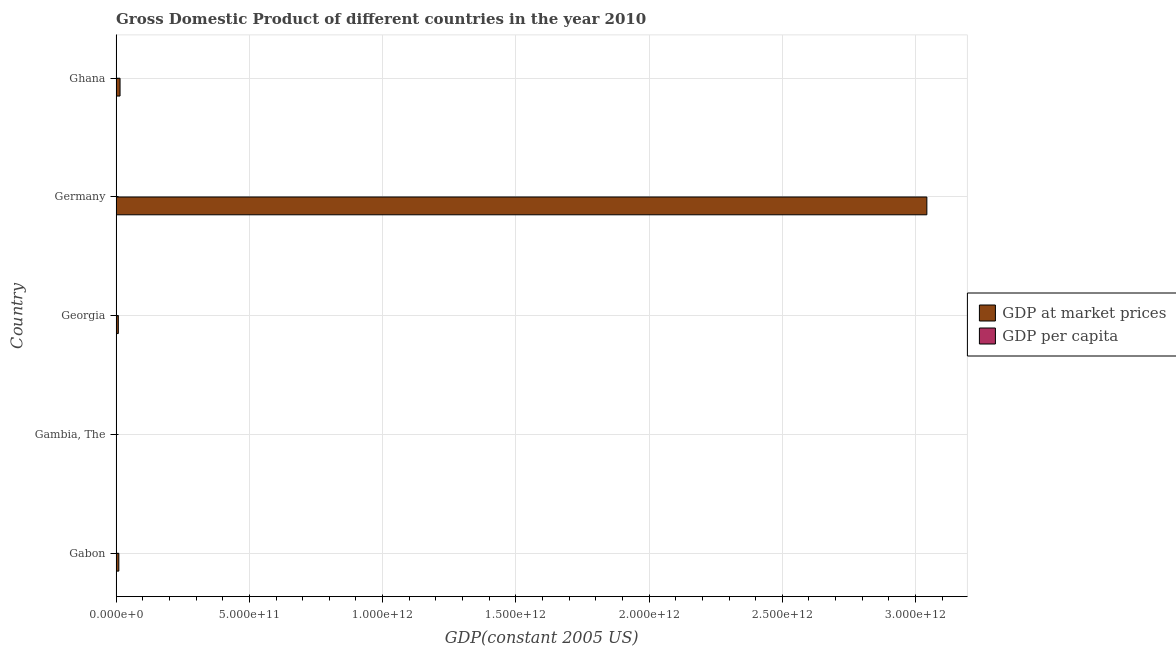How many different coloured bars are there?
Provide a succinct answer. 2. Are the number of bars on each tick of the Y-axis equal?
Give a very brief answer. Yes. How many bars are there on the 1st tick from the top?
Your answer should be very brief. 2. What is the label of the 4th group of bars from the top?
Provide a short and direct response. Gambia, The. What is the gdp at market prices in Gabon?
Provide a succinct answer. 1.01e+1. Across all countries, what is the maximum gdp per capita?
Keep it short and to the point. 3.72e+04. Across all countries, what is the minimum gdp at market prices?
Offer a very short reply. 7.84e+08. In which country was the gdp at market prices maximum?
Your response must be concise. Germany. In which country was the gdp at market prices minimum?
Keep it short and to the point. Gambia, The. What is the total gdp at market prices in the graph?
Keep it short and to the point. 3.08e+12. What is the difference between the gdp per capita in Gambia, The and that in Germany?
Your answer should be compact. -3.67e+04. What is the difference between the gdp per capita in Ghana and the gdp at market prices in Gambia, The?
Ensure brevity in your answer.  -7.84e+08. What is the average gdp per capita per country?
Keep it short and to the point. 9341.05. What is the difference between the gdp at market prices and gdp per capita in Georgia?
Keep it short and to the point. 8.24e+09. In how many countries, is the gdp per capita greater than 2400000000000 US$?
Make the answer very short. 0. What is the ratio of the gdp at market prices in Germany to that in Ghana?
Give a very brief answer. 206.79. Is the gdp at market prices in Georgia less than that in Germany?
Ensure brevity in your answer.  Yes. Is the difference between the gdp per capita in Georgia and Germany greater than the difference between the gdp at market prices in Georgia and Germany?
Make the answer very short. Yes. What is the difference between the highest and the second highest gdp at market prices?
Your response must be concise. 3.03e+12. What is the difference between the highest and the lowest gdp at market prices?
Keep it short and to the point. 3.04e+12. Is the sum of the gdp per capita in Gambia, The and Georgia greater than the maximum gdp at market prices across all countries?
Offer a terse response. No. What does the 1st bar from the top in Gabon represents?
Keep it short and to the point. GDP per capita. What does the 1st bar from the bottom in Germany represents?
Provide a short and direct response. GDP at market prices. How many bars are there?
Offer a very short reply. 10. How many countries are there in the graph?
Your answer should be very brief. 5. What is the difference between two consecutive major ticks on the X-axis?
Give a very brief answer. 5.00e+11. Are the values on the major ticks of X-axis written in scientific E-notation?
Keep it short and to the point. Yes. Does the graph contain any zero values?
Give a very brief answer. No. Does the graph contain grids?
Provide a succinct answer. Yes. How many legend labels are there?
Offer a terse response. 2. What is the title of the graph?
Give a very brief answer. Gross Domestic Product of different countries in the year 2010. What is the label or title of the X-axis?
Your answer should be very brief. GDP(constant 2005 US). What is the GDP(constant 2005 US) of GDP at market prices in Gabon?
Provide a short and direct response. 1.01e+1. What is the GDP(constant 2005 US) in GDP per capita in Gabon?
Keep it short and to the point. 6582.15. What is the GDP(constant 2005 US) of GDP at market prices in Gambia, The?
Make the answer very short. 7.84e+08. What is the GDP(constant 2005 US) of GDP per capita in Gambia, The?
Provide a short and direct response. 463.24. What is the GDP(constant 2005 US) in GDP at market prices in Georgia?
Your answer should be compact. 8.24e+09. What is the GDP(constant 2005 US) in GDP per capita in Georgia?
Your answer should be compact. 1850.76. What is the GDP(constant 2005 US) in GDP at market prices in Germany?
Your answer should be very brief. 3.04e+12. What is the GDP(constant 2005 US) in GDP per capita in Germany?
Your response must be concise. 3.72e+04. What is the GDP(constant 2005 US) of GDP at market prices in Ghana?
Ensure brevity in your answer.  1.47e+1. What is the GDP(constant 2005 US) of GDP per capita in Ghana?
Make the answer very short. 605. Across all countries, what is the maximum GDP(constant 2005 US) of GDP at market prices?
Offer a terse response. 3.04e+12. Across all countries, what is the maximum GDP(constant 2005 US) in GDP per capita?
Your answer should be compact. 3.72e+04. Across all countries, what is the minimum GDP(constant 2005 US) of GDP at market prices?
Provide a short and direct response. 7.84e+08. Across all countries, what is the minimum GDP(constant 2005 US) of GDP per capita?
Your answer should be compact. 463.24. What is the total GDP(constant 2005 US) of GDP at market prices in the graph?
Keep it short and to the point. 3.08e+12. What is the total GDP(constant 2005 US) in GDP per capita in the graph?
Keep it short and to the point. 4.67e+04. What is the difference between the GDP(constant 2005 US) of GDP at market prices in Gabon and that in Gambia, The?
Make the answer very short. 9.36e+09. What is the difference between the GDP(constant 2005 US) in GDP per capita in Gabon and that in Gambia, The?
Offer a terse response. 6118.91. What is the difference between the GDP(constant 2005 US) of GDP at market prices in Gabon and that in Georgia?
Keep it short and to the point. 1.91e+09. What is the difference between the GDP(constant 2005 US) in GDP per capita in Gabon and that in Georgia?
Provide a succinct answer. 4731.39. What is the difference between the GDP(constant 2005 US) of GDP at market prices in Gabon and that in Germany?
Offer a terse response. -3.03e+12. What is the difference between the GDP(constant 2005 US) in GDP per capita in Gabon and that in Germany?
Offer a very short reply. -3.06e+04. What is the difference between the GDP(constant 2005 US) of GDP at market prices in Gabon and that in Ghana?
Offer a terse response. -4.56e+09. What is the difference between the GDP(constant 2005 US) in GDP per capita in Gabon and that in Ghana?
Offer a very short reply. 5977.15. What is the difference between the GDP(constant 2005 US) of GDP at market prices in Gambia, The and that in Georgia?
Offer a very short reply. -7.46e+09. What is the difference between the GDP(constant 2005 US) of GDP per capita in Gambia, The and that in Georgia?
Your answer should be very brief. -1387.52. What is the difference between the GDP(constant 2005 US) of GDP at market prices in Gambia, The and that in Germany?
Offer a very short reply. -3.04e+12. What is the difference between the GDP(constant 2005 US) of GDP per capita in Gambia, The and that in Germany?
Provide a short and direct response. -3.67e+04. What is the difference between the GDP(constant 2005 US) of GDP at market prices in Gambia, The and that in Ghana?
Provide a short and direct response. -1.39e+1. What is the difference between the GDP(constant 2005 US) in GDP per capita in Gambia, The and that in Ghana?
Your response must be concise. -141.76. What is the difference between the GDP(constant 2005 US) of GDP at market prices in Georgia and that in Germany?
Offer a very short reply. -3.03e+12. What is the difference between the GDP(constant 2005 US) in GDP per capita in Georgia and that in Germany?
Your answer should be compact. -3.54e+04. What is the difference between the GDP(constant 2005 US) in GDP at market prices in Georgia and that in Ghana?
Your response must be concise. -6.47e+09. What is the difference between the GDP(constant 2005 US) of GDP per capita in Georgia and that in Ghana?
Keep it short and to the point. 1245.76. What is the difference between the GDP(constant 2005 US) of GDP at market prices in Germany and that in Ghana?
Provide a short and direct response. 3.03e+12. What is the difference between the GDP(constant 2005 US) in GDP per capita in Germany and that in Ghana?
Ensure brevity in your answer.  3.66e+04. What is the difference between the GDP(constant 2005 US) of GDP at market prices in Gabon and the GDP(constant 2005 US) of GDP per capita in Gambia, The?
Keep it short and to the point. 1.01e+1. What is the difference between the GDP(constant 2005 US) in GDP at market prices in Gabon and the GDP(constant 2005 US) in GDP per capita in Georgia?
Your response must be concise. 1.01e+1. What is the difference between the GDP(constant 2005 US) of GDP at market prices in Gabon and the GDP(constant 2005 US) of GDP per capita in Germany?
Make the answer very short. 1.01e+1. What is the difference between the GDP(constant 2005 US) of GDP at market prices in Gabon and the GDP(constant 2005 US) of GDP per capita in Ghana?
Ensure brevity in your answer.  1.01e+1. What is the difference between the GDP(constant 2005 US) of GDP at market prices in Gambia, The and the GDP(constant 2005 US) of GDP per capita in Georgia?
Your response must be concise. 7.84e+08. What is the difference between the GDP(constant 2005 US) of GDP at market prices in Gambia, The and the GDP(constant 2005 US) of GDP per capita in Germany?
Give a very brief answer. 7.84e+08. What is the difference between the GDP(constant 2005 US) in GDP at market prices in Gambia, The and the GDP(constant 2005 US) in GDP per capita in Ghana?
Your answer should be compact. 7.84e+08. What is the difference between the GDP(constant 2005 US) in GDP at market prices in Georgia and the GDP(constant 2005 US) in GDP per capita in Germany?
Provide a short and direct response. 8.24e+09. What is the difference between the GDP(constant 2005 US) of GDP at market prices in Georgia and the GDP(constant 2005 US) of GDP per capita in Ghana?
Give a very brief answer. 8.24e+09. What is the difference between the GDP(constant 2005 US) in GDP at market prices in Germany and the GDP(constant 2005 US) in GDP per capita in Ghana?
Keep it short and to the point. 3.04e+12. What is the average GDP(constant 2005 US) of GDP at market prices per country?
Give a very brief answer. 6.15e+11. What is the average GDP(constant 2005 US) in GDP per capita per country?
Give a very brief answer. 9341.05. What is the difference between the GDP(constant 2005 US) of GDP at market prices and GDP(constant 2005 US) of GDP per capita in Gabon?
Keep it short and to the point. 1.01e+1. What is the difference between the GDP(constant 2005 US) in GDP at market prices and GDP(constant 2005 US) in GDP per capita in Gambia, The?
Offer a very short reply. 7.84e+08. What is the difference between the GDP(constant 2005 US) in GDP at market prices and GDP(constant 2005 US) in GDP per capita in Georgia?
Offer a terse response. 8.24e+09. What is the difference between the GDP(constant 2005 US) in GDP at market prices and GDP(constant 2005 US) in GDP per capita in Germany?
Keep it short and to the point. 3.04e+12. What is the difference between the GDP(constant 2005 US) of GDP at market prices and GDP(constant 2005 US) of GDP per capita in Ghana?
Provide a succinct answer. 1.47e+1. What is the ratio of the GDP(constant 2005 US) of GDP at market prices in Gabon to that in Gambia, The?
Offer a very short reply. 12.94. What is the ratio of the GDP(constant 2005 US) of GDP per capita in Gabon to that in Gambia, The?
Provide a succinct answer. 14.21. What is the ratio of the GDP(constant 2005 US) in GDP at market prices in Gabon to that in Georgia?
Keep it short and to the point. 1.23. What is the ratio of the GDP(constant 2005 US) of GDP per capita in Gabon to that in Georgia?
Your answer should be compact. 3.56. What is the ratio of the GDP(constant 2005 US) in GDP at market prices in Gabon to that in Germany?
Your answer should be very brief. 0. What is the ratio of the GDP(constant 2005 US) in GDP per capita in Gabon to that in Germany?
Your answer should be very brief. 0.18. What is the ratio of the GDP(constant 2005 US) in GDP at market prices in Gabon to that in Ghana?
Your answer should be compact. 0.69. What is the ratio of the GDP(constant 2005 US) in GDP per capita in Gabon to that in Ghana?
Provide a short and direct response. 10.88. What is the ratio of the GDP(constant 2005 US) of GDP at market prices in Gambia, The to that in Georgia?
Provide a short and direct response. 0.1. What is the ratio of the GDP(constant 2005 US) in GDP per capita in Gambia, The to that in Georgia?
Offer a very short reply. 0.25. What is the ratio of the GDP(constant 2005 US) of GDP at market prices in Gambia, The to that in Germany?
Make the answer very short. 0. What is the ratio of the GDP(constant 2005 US) in GDP per capita in Gambia, The to that in Germany?
Keep it short and to the point. 0.01. What is the ratio of the GDP(constant 2005 US) of GDP at market prices in Gambia, The to that in Ghana?
Keep it short and to the point. 0.05. What is the ratio of the GDP(constant 2005 US) in GDP per capita in Gambia, The to that in Ghana?
Provide a succinct answer. 0.77. What is the ratio of the GDP(constant 2005 US) in GDP at market prices in Georgia to that in Germany?
Provide a short and direct response. 0. What is the ratio of the GDP(constant 2005 US) of GDP per capita in Georgia to that in Germany?
Your answer should be compact. 0.05. What is the ratio of the GDP(constant 2005 US) of GDP at market prices in Georgia to that in Ghana?
Make the answer very short. 0.56. What is the ratio of the GDP(constant 2005 US) in GDP per capita in Georgia to that in Ghana?
Your answer should be compact. 3.06. What is the ratio of the GDP(constant 2005 US) of GDP at market prices in Germany to that in Ghana?
Keep it short and to the point. 206.8. What is the ratio of the GDP(constant 2005 US) in GDP per capita in Germany to that in Ghana?
Your response must be concise. 61.49. What is the difference between the highest and the second highest GDP(constant 2005 US) of GDP at market prices?
Your response must be concise. 3.03e+12. What is the difference between the highest and the second highest GDP(constant 2005 US) of GDP per capita?
Offer a very short reply. 3.06e+04. What is the difference between the highest and the lowest GDP(constant 2005 US) in GDP at market prices?
Keep it short and to the point. 3.04e+12. What is the difference between the highest and the lowest GDP(constant 2005 US) in GDP per capita?
Your answer should be compact. 3.67e+04. 